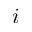<formula> <loc_0><loc_0><loc_500><loc_500>i</formula> 